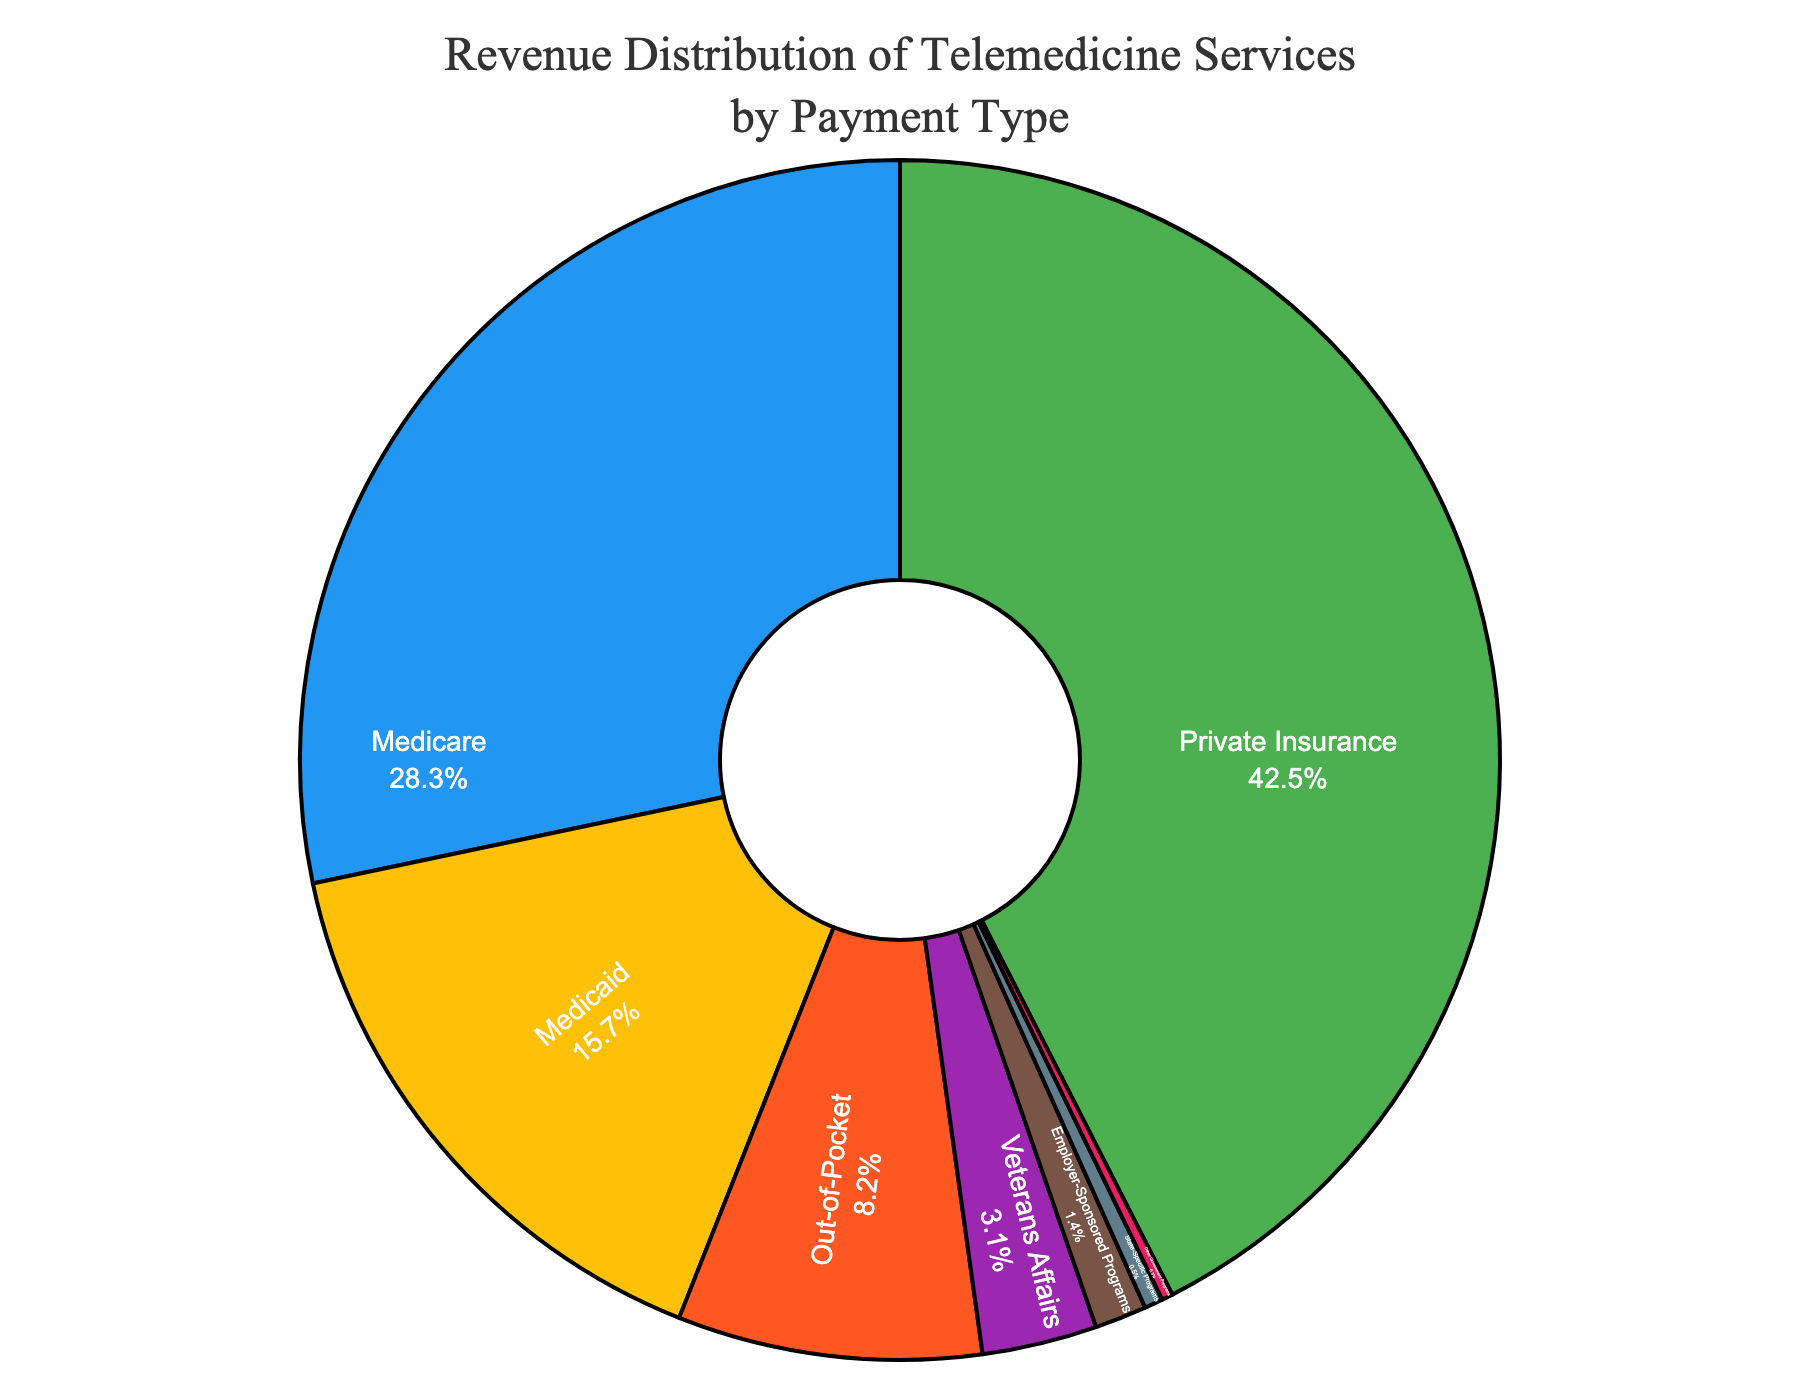What is the most common payment type for telemedicine services? Identify the slice that has the largest portion of the pie chart to determine the most common payment type. The largest slice represents Private Insurance at 42.5%.
Answer: Private Insurance What percentage of revenue comes from government programs combined (Medicare, Medicaid, Veterans Affairs, State-Specific Programs, Other Government Programs)? Sum the percentages of all government programs: Medicare (28.3%) + Medicaid (15.7%) + Veterans Affairs (3.1%) + State-Specific Programs (0.5%) + Other Government Programs (0.3%) = 47.9%.
Answer: 47.9% How does the revenue from Private Insurance compare to the revenue from Out-of-Pocket payments? Look at the percentage for Private Insurance (42.5%) and compare it to Out-of-Pocket payments (8.2%). Private Insurance revenue is significantly higher.
Answer: Private Insurance is higher Which payment type accounts for less than 1% of the revenue? Identify the slices with percentages less than 1%. Both State-Specific Programs (0.5%) and Other Government Programs (0.3%) fit this criterion.
Answer: State-Specific Programs and Other Government Programs What is the total revenue percentage from Private Insurance and Employer-Sponsored Programs combined? Sum the percentages of Private Insurance (42.5%) and Employer-Sponsored Programs (1.4%): 42.5% + 1.4% = 43.9%.
Answer: 43.9% Is the revenue from Medicaid greater than that from Out-of-Pocket payments? Compare the percentages: Medicaid (15.7%) vs. Out-of-Pocket payments (8.2%). Medicaid has a higher percentage.
Answer: Yes, Medicaid is greater What is the visual color assigned to Medicare revenue in the pie chart? Identify the color of the slice labeled Medicare in the pie chart. Medicare's slice is assigned the color blue.
Answer: Blue What is the difference in percentage between the highest revenue type and the lowest revenue type? Subtract the percentage of the lowest revenue type (Other Government Programs, 0.3%) from the highest revenue type (Private Insurance, 42.5%): 42.5% - 0.3% = 42.2%.
Answer: 42.2% What are the payment types that collectively contribute to around 10% of the revenue? Identify and sum up percentages for payment types that total around 10%. Out-of-Pocket (8.2%) and Veterans Affairs (3.1%) together sum to 11.3%, close to 10%.
Answer: Out-of-Pocket and Veterans Affairs 